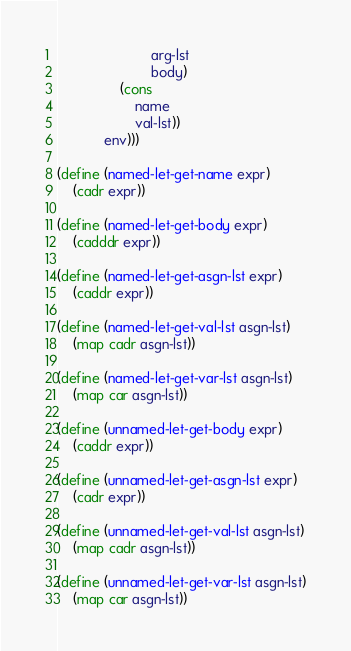<code> <loc_0><loc_0><loc_500><loc_500><_Scheme_>						arg-lst
						body)
				(cons
					name
					val-lst))
			env)))

(define (named-let-get-name expr)
	(cadr expr))

(define (named-let-get-body expr)
	(cadddr expr))

(define (named-let-get-asgn-lst expr)
	(caddr expr))

(define (named-let-get-val-lst asgn-lst)
	(map cadr asgn-lst))

(define (named-let-get-var-lst asgn-lst)
	(map car asgn-lst))

(define (unnamed-let-get-body expr)
	(caddr expr))

(define (unnamed-let-get-asgn-lst expr)
	(cadr expr))

(define (unnamed-let-get-val-lst asgn-lst)
	(map cadr asgn-lst))

(define (unnamed-let-get-var-lst asgn-lst)
	(map car asgn-lst))
</code> 